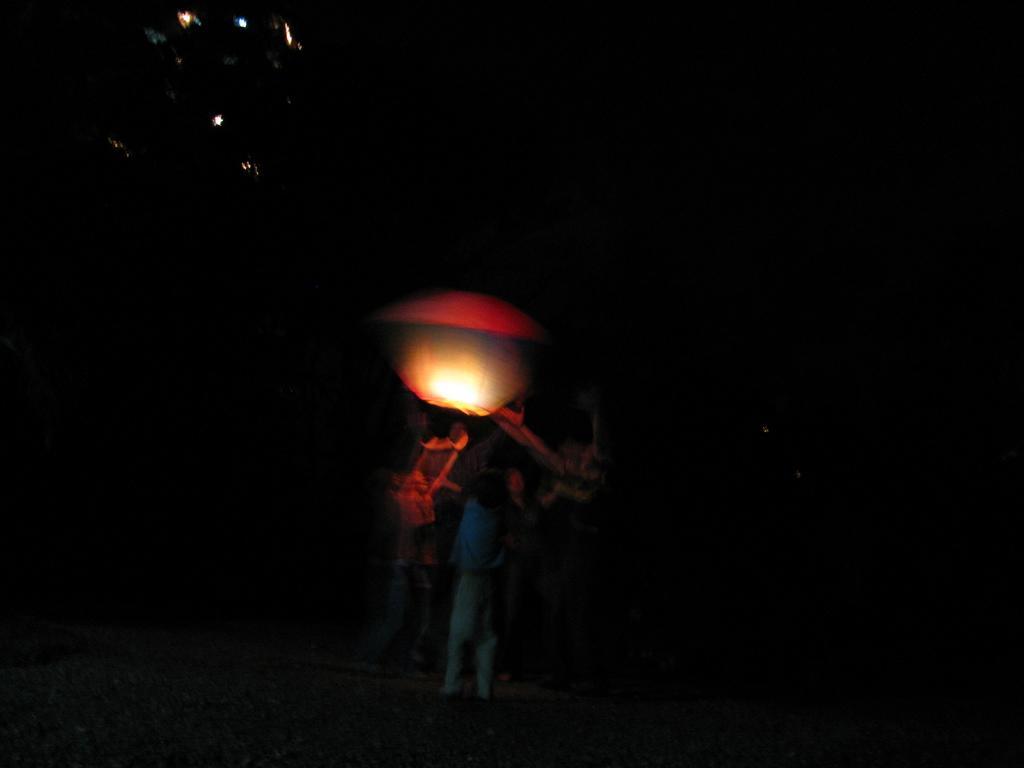How would you summarize this image in a sentence or two? This image is taken outdoors. In this image the background is dark. In the middle of the image there is a person and there is a light. 